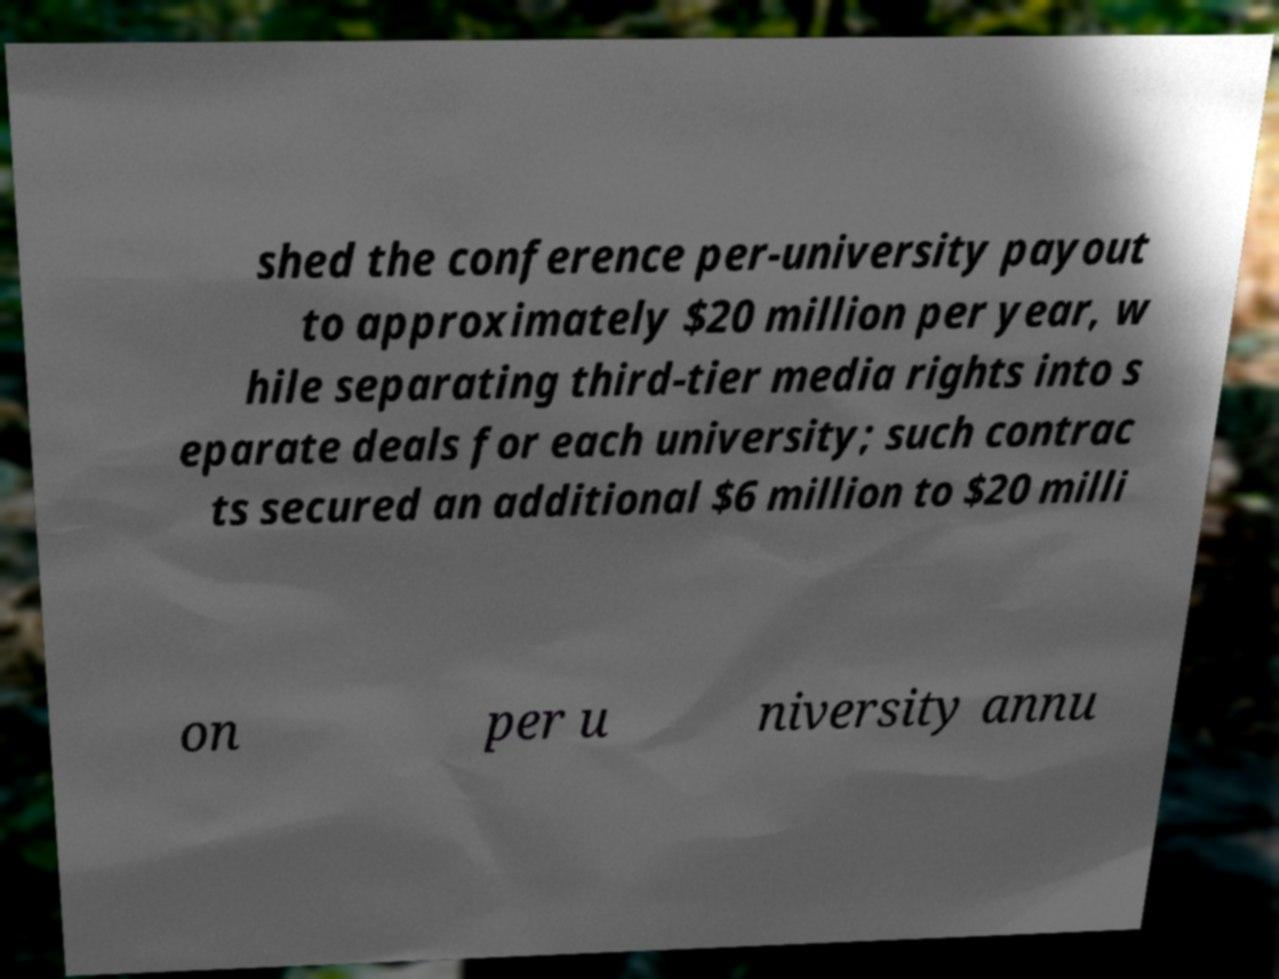Can you accurately transcribe the text from the provided image for me? shed the conference per-university payout to approximately $20 million per year, w hile separating third-tier media rights into s eparate deals for each university; such contrac ts secured an additional $6 million to $20 milli on per u niversity annu 